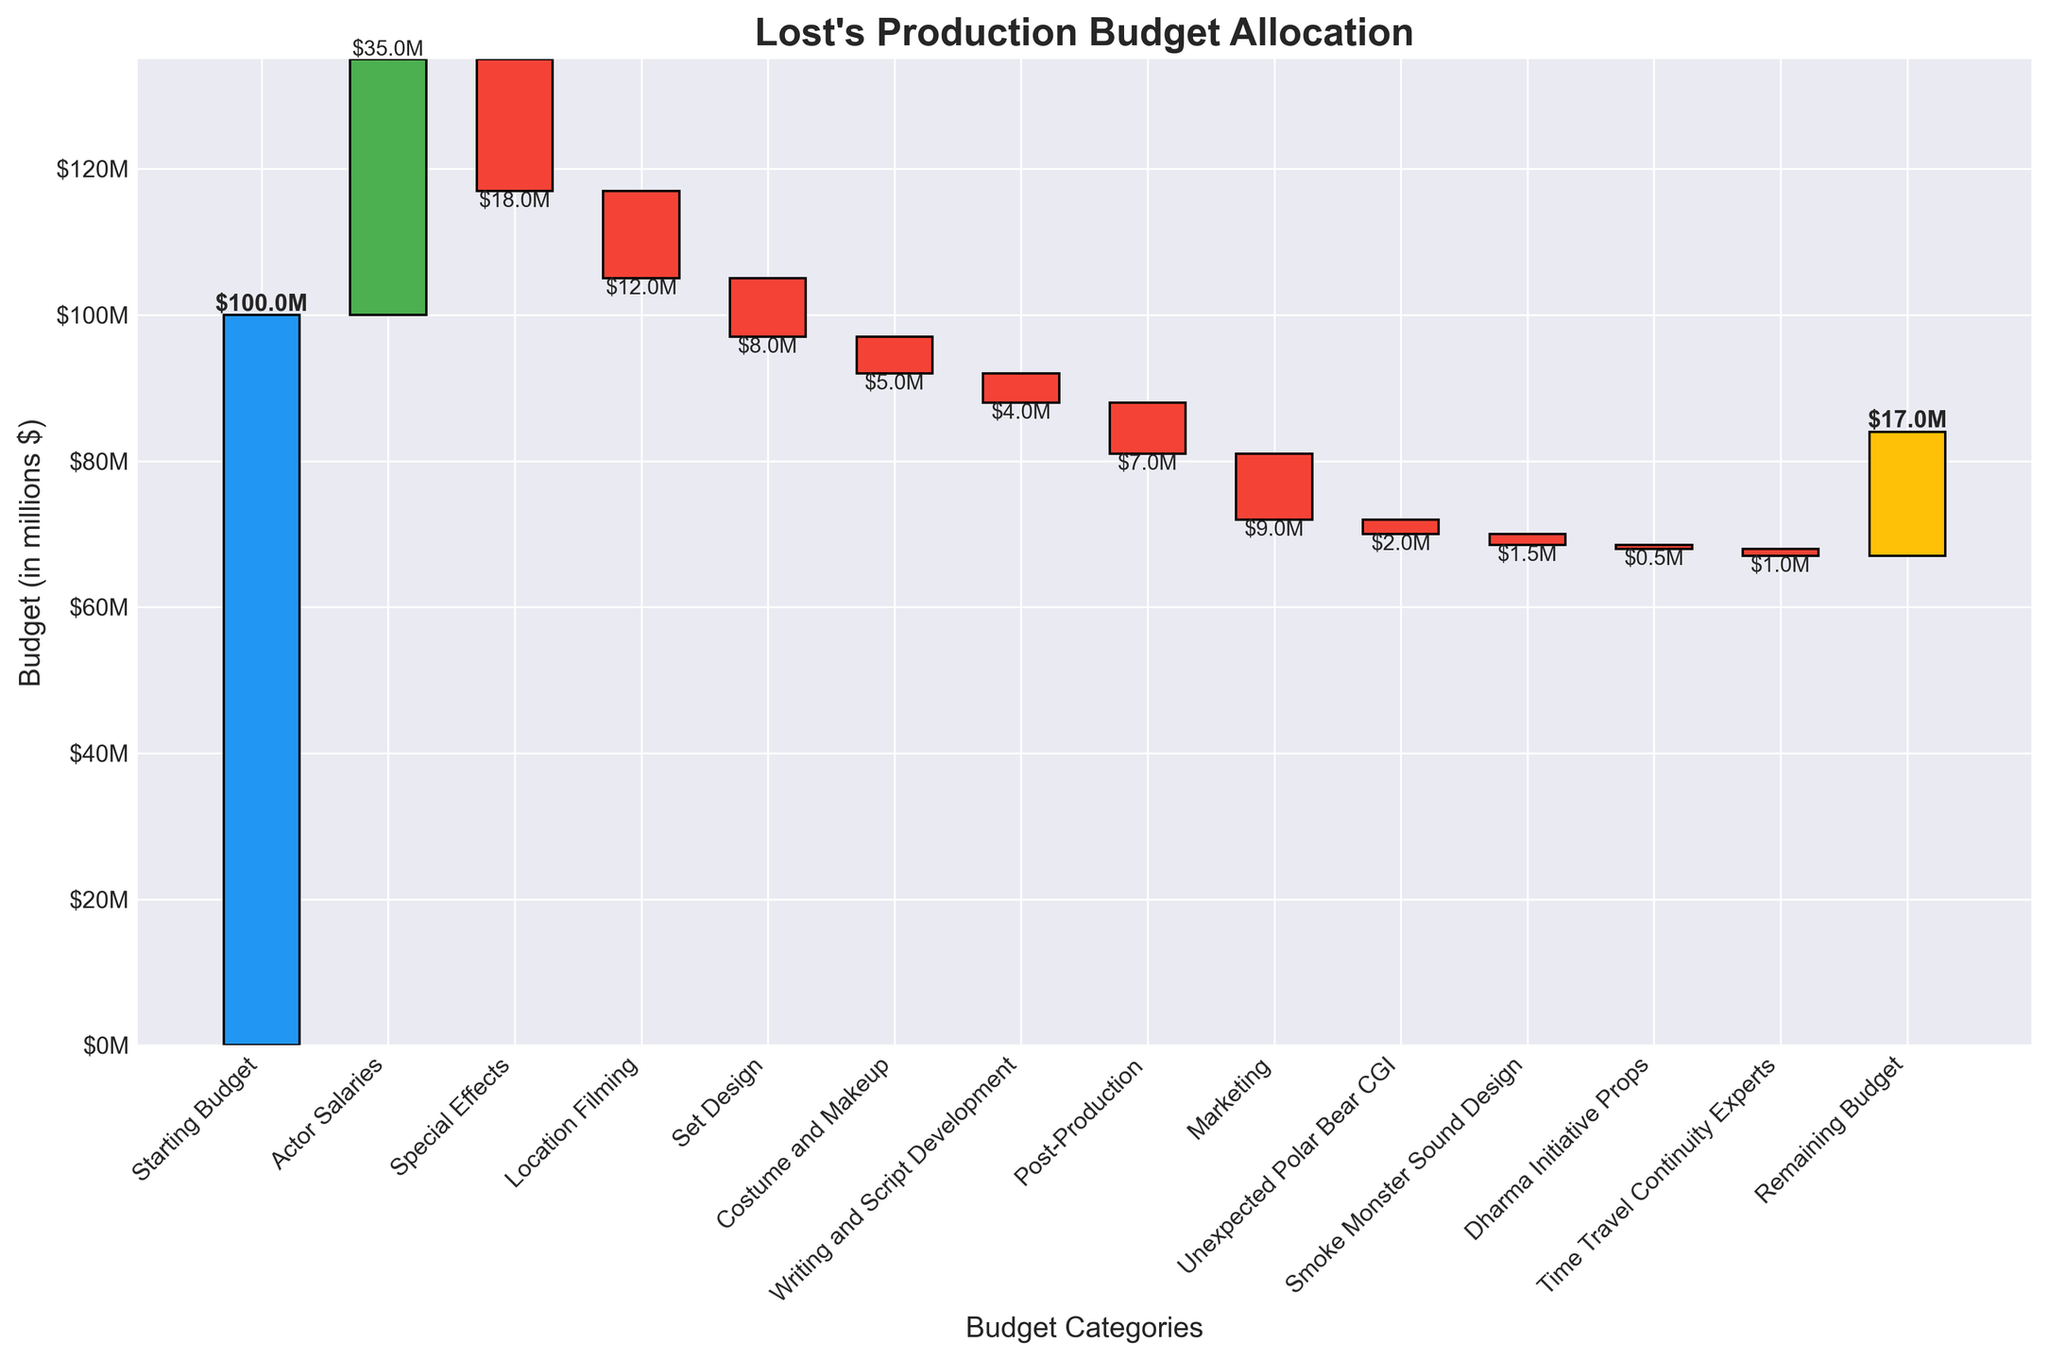What is the starting budget for Lost's production? The starting budget is indicated at the beginning of the waterfall chart. It is represented by the first bar labeled "Starting Budget."
Answer: $100 million What is the title of this chart? The chart title is found at the top of the figure.
Answer: Lost's Production Budget Allocation Which budget category had the highest allocation? By comparing the heights of the bars, the "Actor Salaries" category has the highest allocation.
Answer: Actor Salaries What are the cumulative amounts after allocating funds for Actor Salaries and Special Effects? From the chart, the Actor Salaries allocation is $35 million, making the cumulative amount $135 million. After subtracting $18 million for Special Effects, the cumulative amount is $117 million.
Answer: $117 million How does the Remaining Budget compare to the Unexpected Polar Bear CGI allocation? The remaining budget is $17 million, whereas the Unexpected Polar Bear CGI allocation is $2 million. The Remaining Budget is greater.
Answer: Remaining Budget is greater What is the total amount allocated to both Post-Production and Marketing together? From the chart, the Post-Production allocation is $7 million and the Marketing allocation is $9 million. Summing these two values gives a total of $16 million.
Answer: $16 million Which expense category resulted in a decrease of funds by $5 million? By checking the values and color of each bar, the "Costume and Makeup" category results in a $5 million decrease, highlighted by a red bar.
Answer: Costume and Makeup What is the cumulative budget just before the Remaining Budget? The cumulative amount right before the Remaining Budget is the sum of all previous values. Step-by-step: $100M - $35M - $18M - $12M - $8M - $5M - $4M - $7M - $9M - $2M - $1.5M - $0.5M - $1M + $17M = $17M.
Answer: $17 million What is the net change in budget due to Special Effects, Location Filming, and Set Design together? Special Effects is a decrease of $18M, Location Filming is a decrease of $12M, and Set Design is a decrease of $8M. Sum these changes: $(-18M) + $(-12M) + $(-8M) = $(-38M).
Answer: -$38 million Why is the Unexpected Polar Bear CGI category indicated in the chart, and what is its value? It represents an unexpected expense depicted by the corresponding red bar, valued at $2 million.
Answer: $2 million 